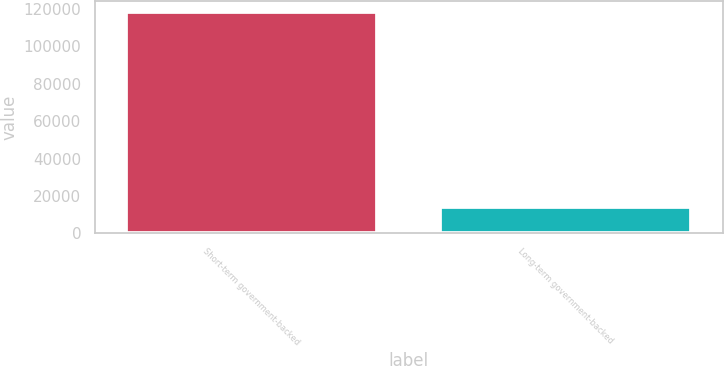<chart> <loc_0><loc_0><loc_500><loc_500><bar_chart><fcel>Short-term government-backed<fcel>Long-term government-backed<nl><fcel>118125<fcel>13999<nl></chart> 